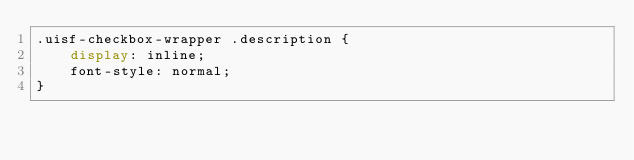<code> <loc_0><loc_0><loc_500><loc_500><_CSS_>.uisf-checkbox-wrapper .description {
	display: inline;
	font-style: normal;
}
</code> 